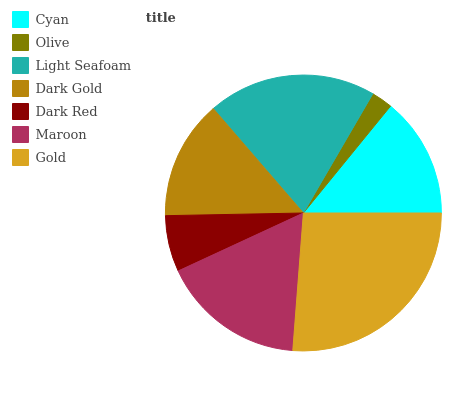Is Olive the minimum?
Answer yes or no. Yes. Is Gold the maximum?
Answer yes or no. Yes. Is Light Seafoam the minimum?
Answer yes or no. No. Is Light Seafoam the maximum?
Answer yes or no. No. Is Light Seafoam greater than Olive?
Answer yes or no. Yes. Is Olive less than Light Seafoam?
Answer yes or no. Yes. Is Olive greater than Light Seafoam?
Answer yes or no. No. Is Light Seafoam less than Olive?
Answer yes or no. No. Is Cyan the high median?
Answer yes or no. Yes. Is Cyan the low median?
Answer yes or no. Yes. Is Olive the high median?
Answer yes or no. No. Is Dark Gold the low median?
Answer yes or no. No. 